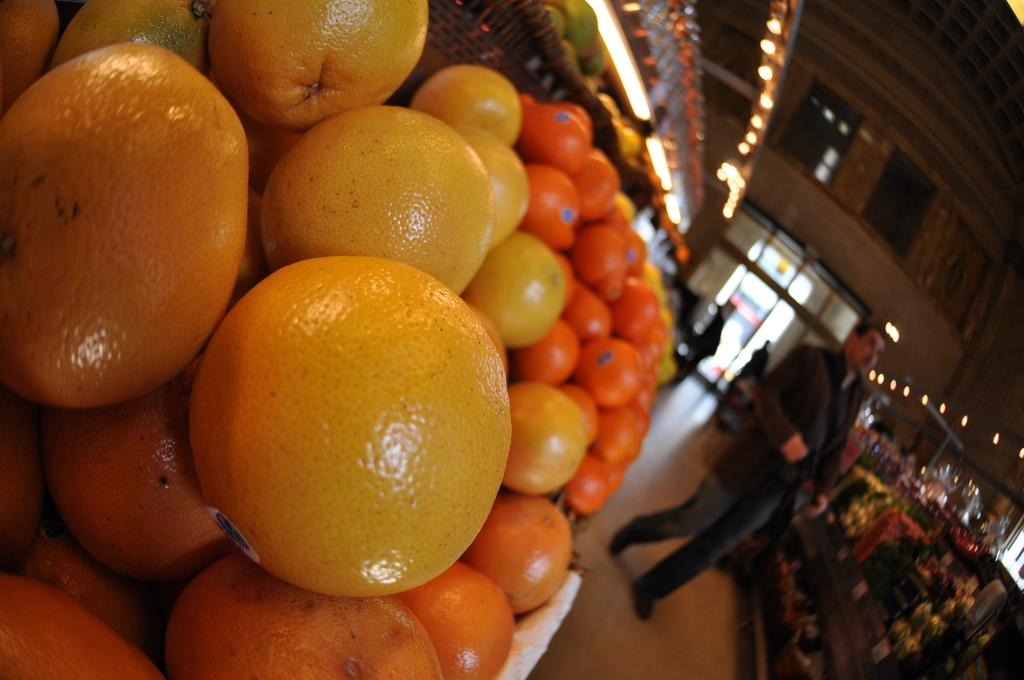What type of establishment is depicted in the image? There is a store in the image. What can be found inside the store? There are many fruits in the store. How many people are visible in the image? There are few people in the image. What is the entrance to the store like? There is a door in the image. What is the lighting situation in the image? There are many lights in the image. What type of locket is hanging from the ceiling in the image? There is no locket present in the image; it is a store with many fruits and lights. 